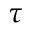Convert formula to latex. <formula><loc_0><loc_0><loc_500><loc_500>\tau</formula> 